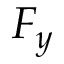Convert formula to latex. <formula><loc_0><loc_0><loc_500><loc_500>F _ { y }</formula> 